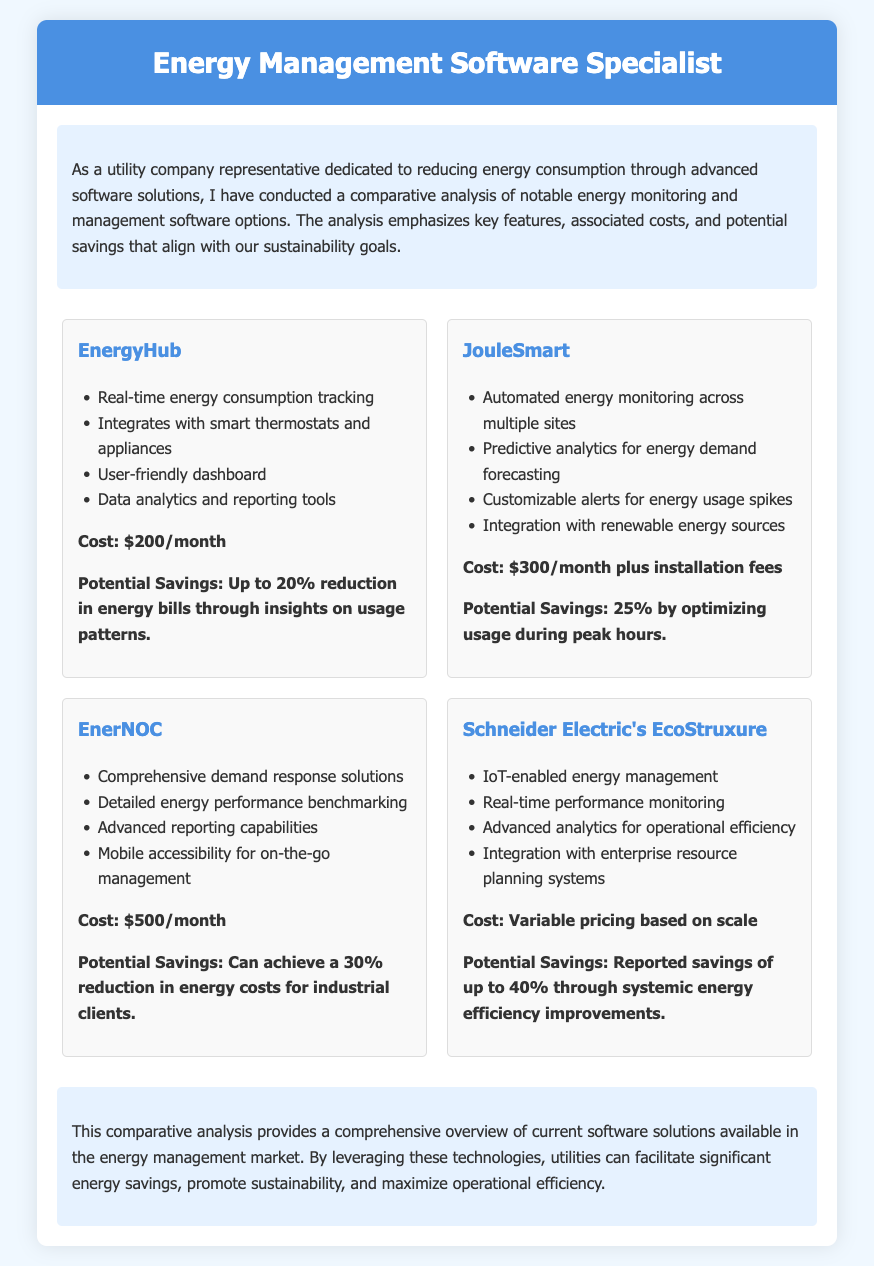What is the title of the document? The title of the document is prominently displayed at the top, indicating the individual's professional focus.
Answer: Energy Management Software Specialist How many software solutions are analyzed in the document? The document lists four distinct software solutions, showcasing different options available.
Answer: Four What is the cost of EnergyHub? The cost of EnergyHub is stated clearly, providing potential users with the financial requirement.
Answer: $200/month What potential savings does JouleSmart offer? The document outlines the savings goal associated with JouleSmart, revealing its efficiency.
Answer: 25% What key feature is highlighted for Schneider Electric's EcoStruxure? The document emphasizes a distinctive feature that sets Schneider Electric's offering apart in the market.
Answer: IoT-enabled energy management Which software solution has the highest potential savings percentage? By comparing the potential savings across all solutions, one can identify which software offers the best savings estimate.
Answer: Schneider Electric's EcoStruxure (40%) What type of analytics does EnerNOC provide? The document mentions specific capabilities related to EnerNOC’s functionality for energy management.
Answer: Advanced reporting capabilities What is the main goal as a utility company representative mentioned in the document? The document states the overarching aim of the representative, reflecting their focus on sustainability.
Answer: Reducing energy consumption 